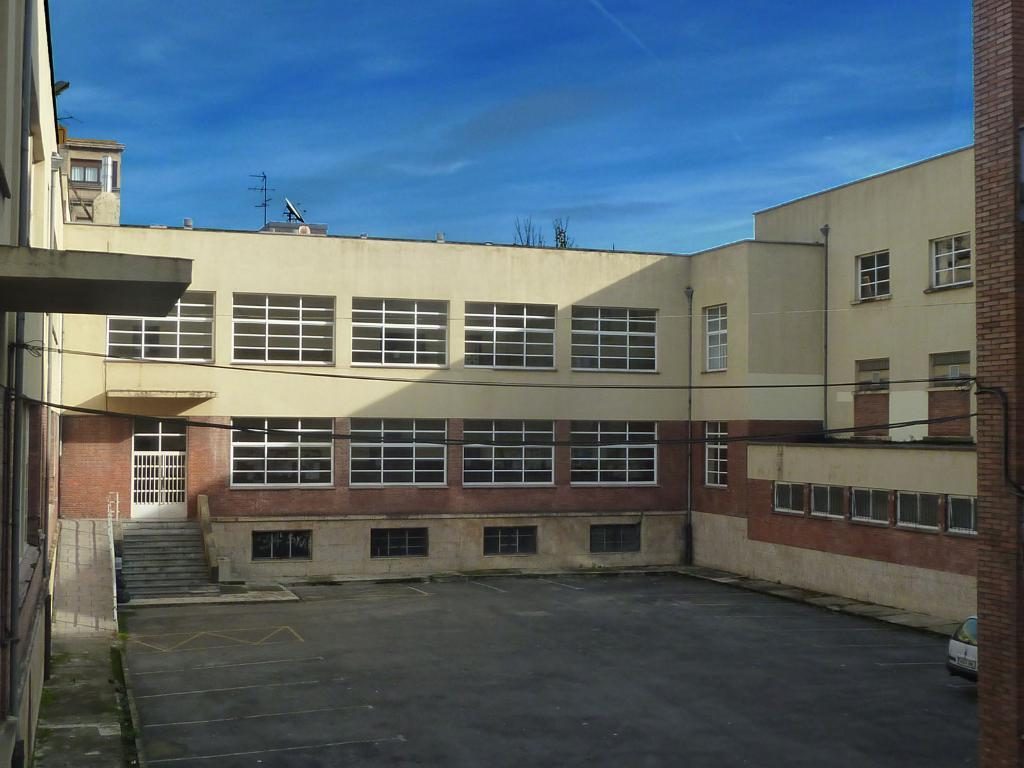What can be seen on the right side of the image? There is a vehicle on the right side of the image. What type of building is in the middle of the image? There is a building with glass windows in the middle of the image. What is visible at the top of the image? The sky is visible at the top of the image. How many bears are sitting on the roof of the building in the image? There are no bears present in the image; it features a vehicle and a building with glass windows. What type of cork is used to seal the windows of the building in the image? There is no mention of cork or any sealing material for the windows in the image; the building has glass windows. 